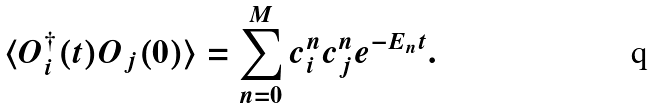<formula> <loc_0><loc_0><loc_500><loc_500>\langle O _ { i } ^ { \dagger } ( t ) O _ { j } ( 0 ) \rangle = \sum _ { n = 0 } ^ { M } c _ { i } ^ { n } c _ { j } ^ { n } e ^ { - E _ { n } t } .</formula> 